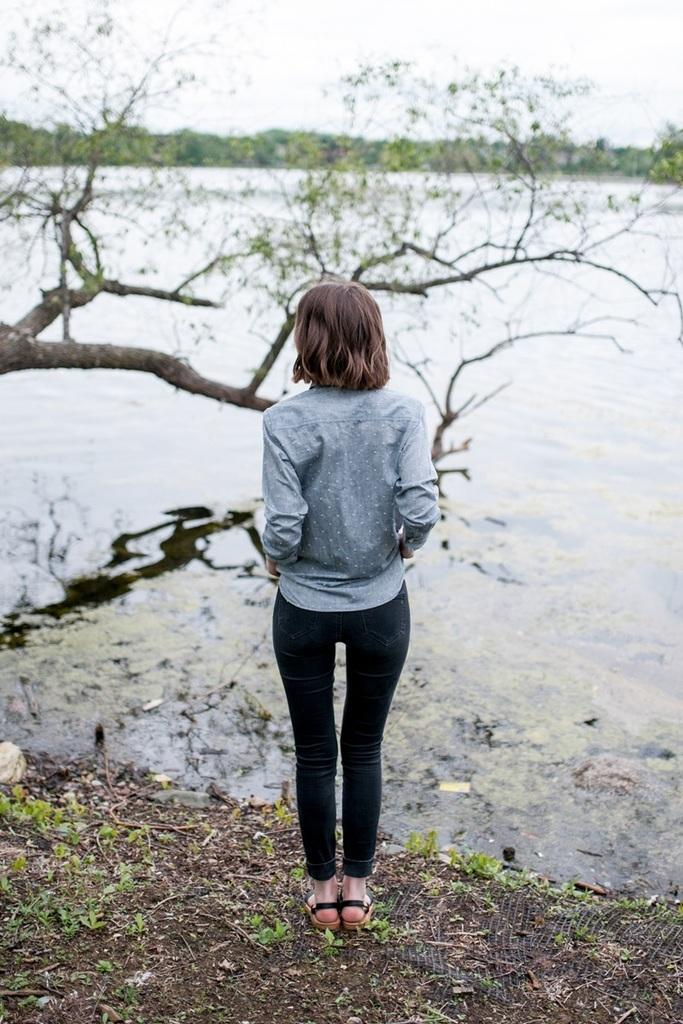Who is the main subject in the image? There is a lady standing in the center of the image. What can be seen in the background of the image? There is water and trees visible in the background of the image. What is visible at the top of the image? The sky is visible at the top of the image. What type of cream is being used in the operation depicted in the image? There is no operation or cream present in the image; it features a lady standing in the center with water, trees, and the sky visible in the background. 